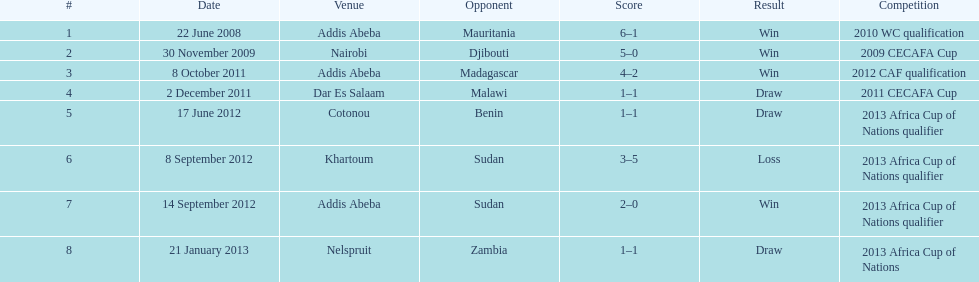What date corresponds to their single setback? 8 September 2012. 